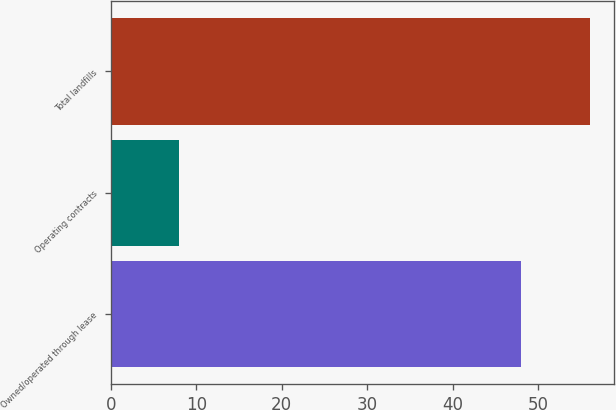Convert chart to OTSL. <chart><loc_0><loc_0><loc_500><loc_500><bar_chart><fcel>Owned/operated through lease<fcel>Operating contracts<fcel>Total landfills<nl><fcel>48<fcel>8<fcel>56<nl></chart> 